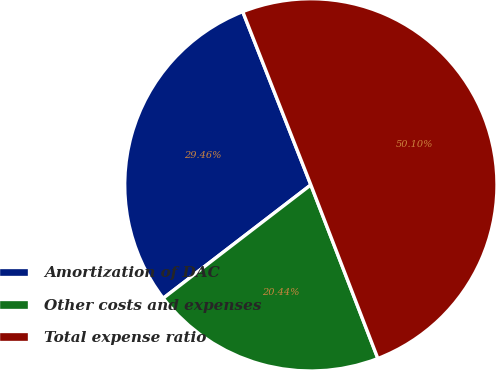Convert chart to OTSL. <chart><loc_0><loc_0><loc_500><loc_500><pie_chart><fcel>Amortization of DAC<fcel>Other costs and expenses<fcel>Total expense ratio<nl><fcel>29.46%<fcel>20.44%<fcel>50.1%<nl></chart> 